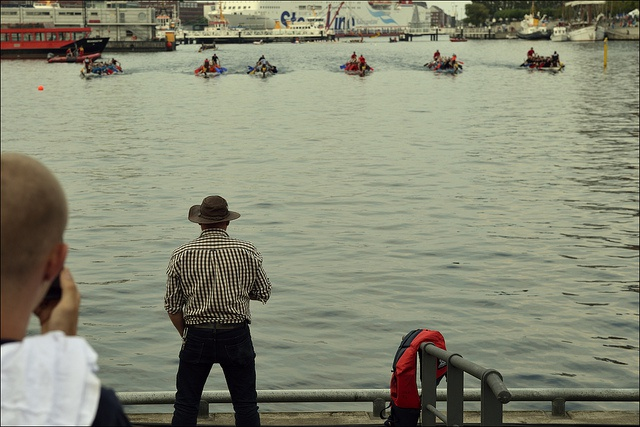Describe the objects in this image and their specific colors. I can see people in black, lightgray, and maroon tones, people in black, darkgray, and gray tones, boat in black, brown, maroon, and gray tones, people in black, darkgray, gray, and maroon tones, and boat in black, tan, and gray tones in this image. 